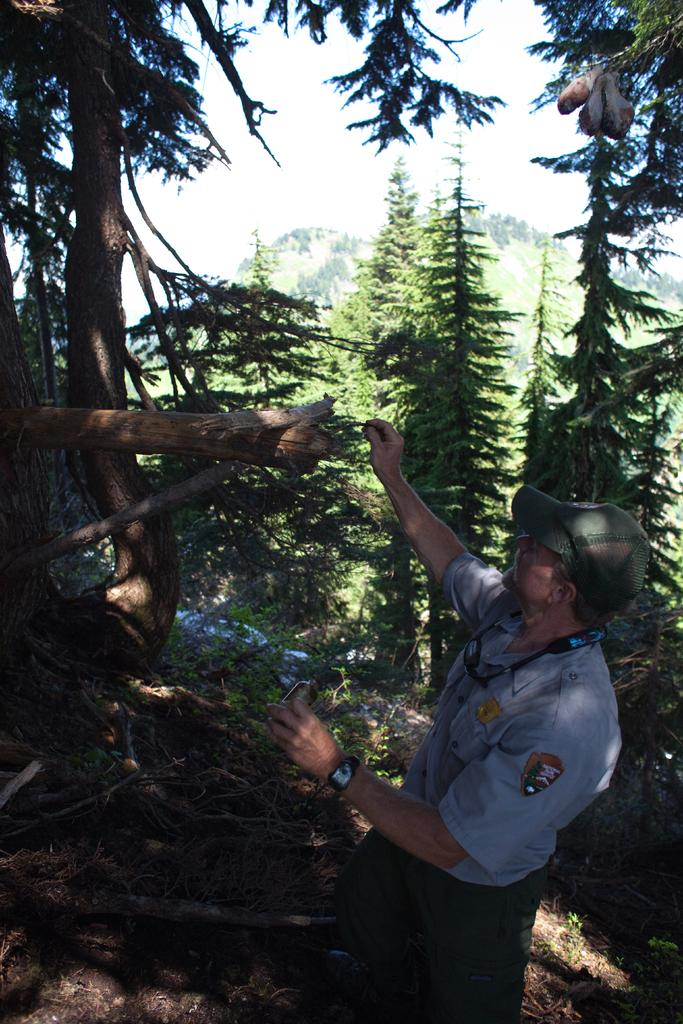Who is present in the image? There is a man in the image. Where is the man located in the image? The man is on the right side of the image. What type of environment is depicted in the image? There is greenery in the image, suggesting a natural or outdoor setting. What type of wool is the man using to write on the chalkboard in the image? There is no chalkboard or wool present in the image. What type of insurance does the man have for his car in the image? There is no car or insurance information present in the image. 